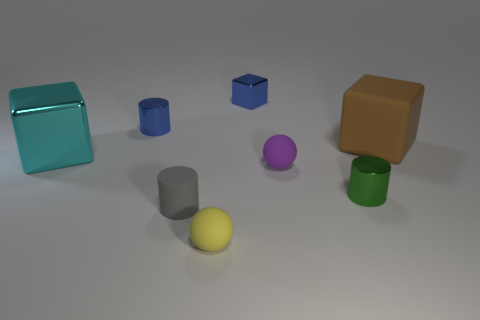Subtract all tiny blue cylinders. How many cylinders are left? 2 Subtract 1 cubes. How many cubes are left? 2 Subtract all green blocks. Subtract all cyan cylinders. How many blocks are left? 3 Add 1 big cubes. How many objects exist? 9 Subtract all cylinders. How many objects are left? 5 Subtract 0 red blocks. How many objects are left? 8 Subtract all green objects. Subtract all tiny blue shiny blocks. How many objects are left? 6 Add 2 green cylinders. How many green cylinders are left? 3 Add 1 big blue matte objects. How many big blue matte objects exist? 1 